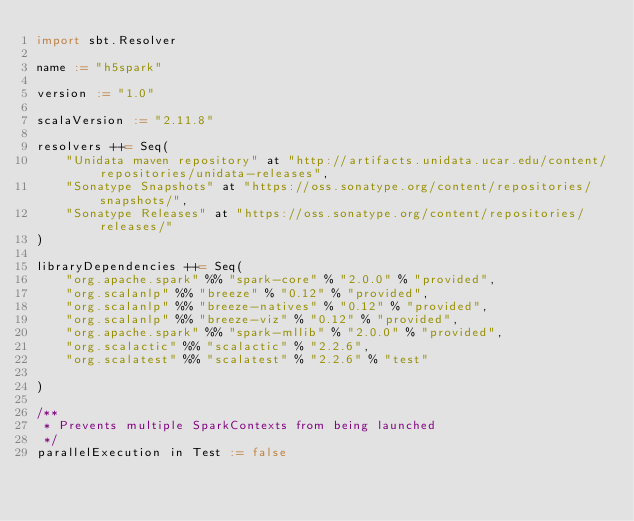Convert code to text. <code><loc_0><loc_0><loc_500><loc_500><_Scala_>import sbt.Resolver

name := "h5spark"

version := "1.0"

scalaVersion := "2.11.8"

resolvers ++= Seq(
	"Unidata maven repository" at "http://artifacts.unidata.ucar.edu/content/repositories/unidata-releases",
	"Sonatype Snapshots" at "https://oss.sonatype.org/content/repositories/snapshots/",
  	"Sonatype Releases" at "https://oss.sonatype.org/content/repositories/releases/"
)

libraryDependencies ++= Seq(
    "org.apache.spark" %% "spark-core" % "2.0.0" % "provided", 
    "org.scalanlp" %% "breeze" % "0.12" % "provided",
    "org.scalanlp" %% "breeze-natives" % "0.12" % "provided",
    "org.scalanlp" %% "breeze-viz" % "0.12" % "provided",
    "org.apache.spark" %% "spark-mllib" % "2.0.0" % "provided",
    "org.scalactic" %% "scalactic" % "2.2.6",
    "org.scalatest" %% "scalatest" % "2.2.6" % "test"

)

/**
 * Prevents multiple SparkContexts from being launched
 */
parallelExecution in Test := false



</code> 